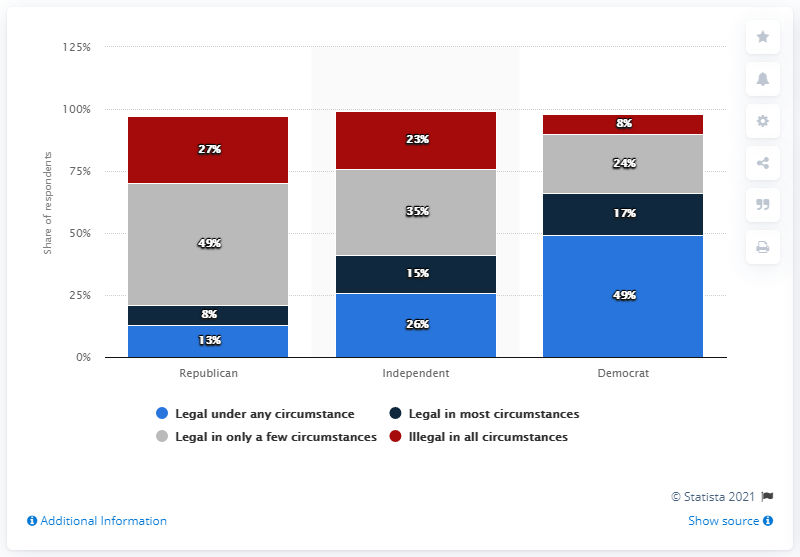Identify some key points in this picture. The average value of the color blue is 29.33. The highest percentage number in the chart is 49%. According to a recent survey, 13% of Republicans supported the legalization of abortion. 